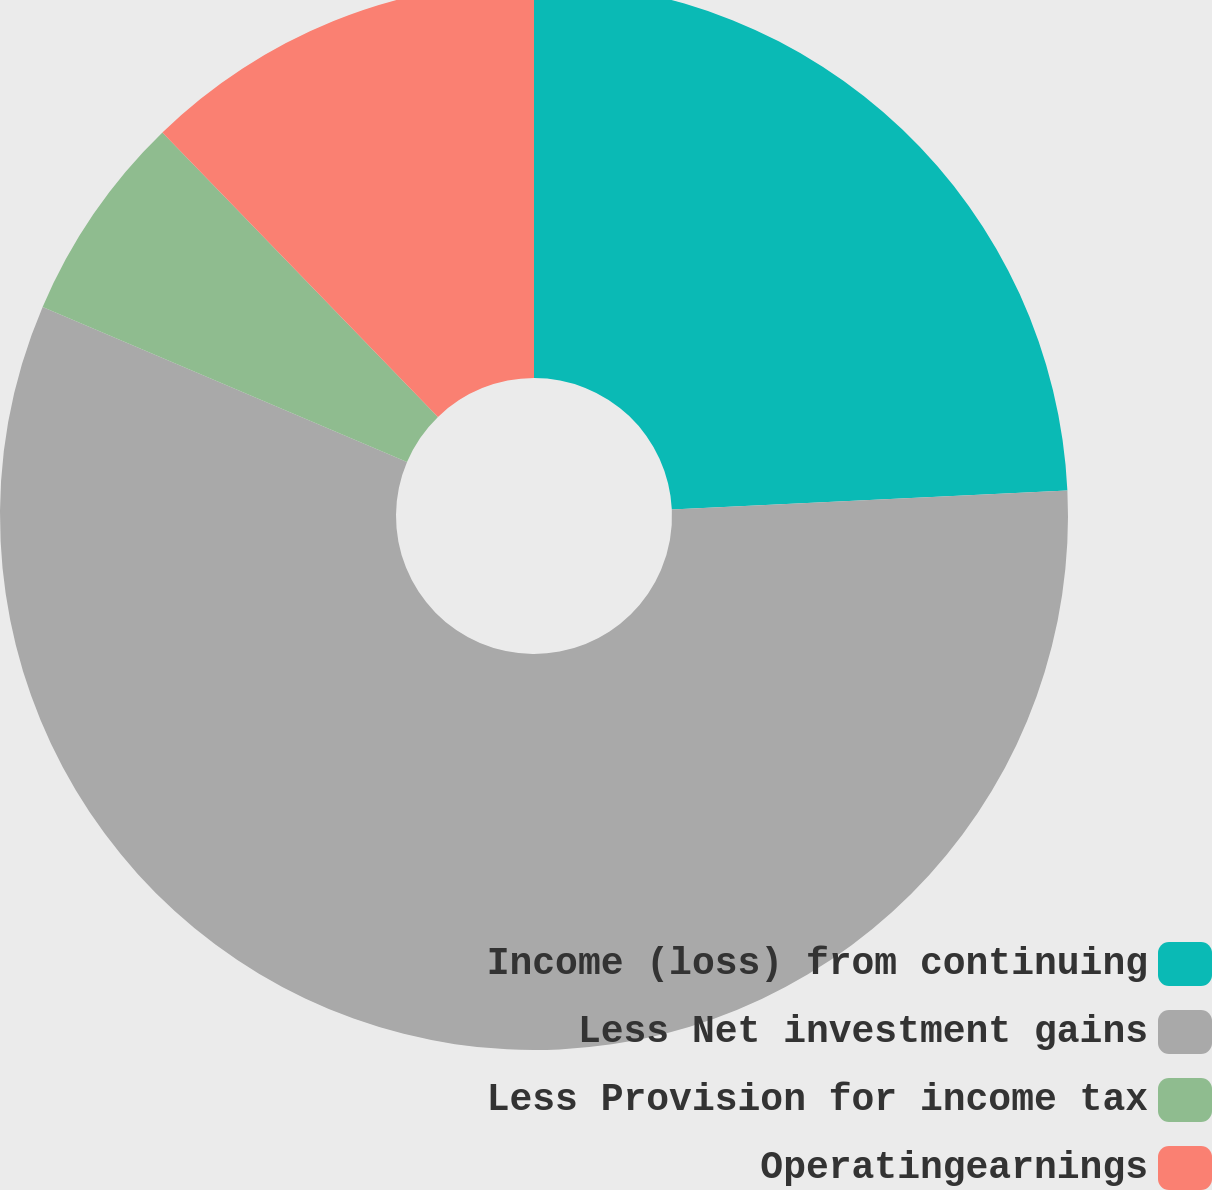Convert chart. <chart><loc_0><loc_0><loc_500><loc_500><pie_chart><fcel>Income (loss) from continuing<fcel>Less Net investment gains<fcel>Less Provision for income tax<fcel>Operatingearnings<nl><fcel>24.24%<fcel>57.17%<fcel>6.35%<fcel>12.25%<nl></chart> 